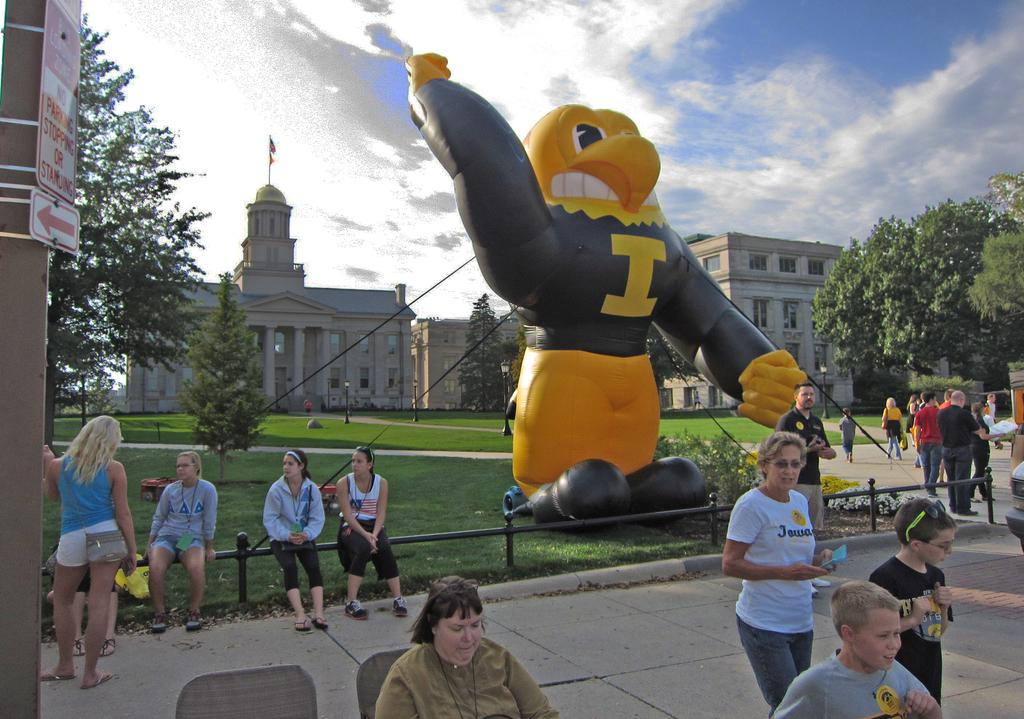<image>
Describe the image concisely. A giant blow up eagle with an I on it's shirt is surrounded by people. 